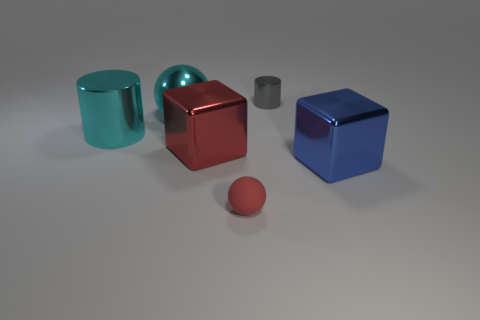Add 2 big red shiny objects. How many objects exist? 8 Subtract all cylinders. How many objects are left? 4 Add 4 blue objects. How many blue objects are left? 5 Add 1 gray cylinders. How many gray cylinders exist? 2 Subtract 0 brown balls. How many objects are left? 6 Subtract all tiny brown blocks. Subtract all cyan spheres. How many objects are left? 5 